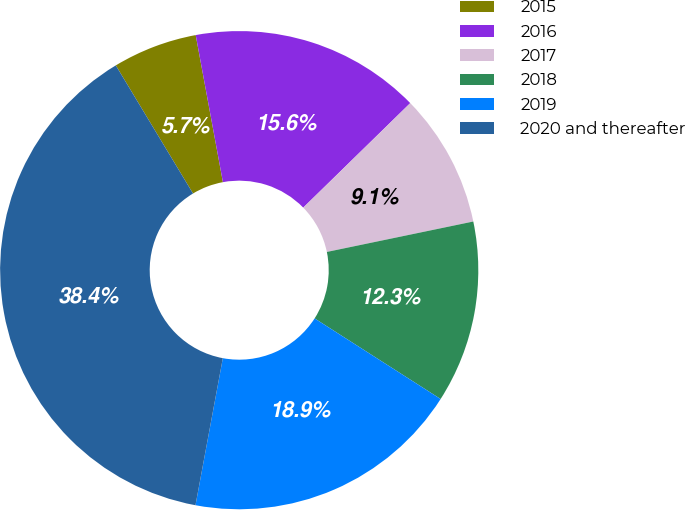Convert chart. <chart><loc_0><loc_0><loc_500><loc_500><pie_chart><fcel>2015<fcel>2016<fcel>2017<fcel>2018<fcel>2019<fcel>2020 and thereafter<nl><fcel>5.72%<fcel>15.6%<fcel>9.05%<fcel>12.32%<fcel>18.87%<fcel>38.44%<nl></chart> 